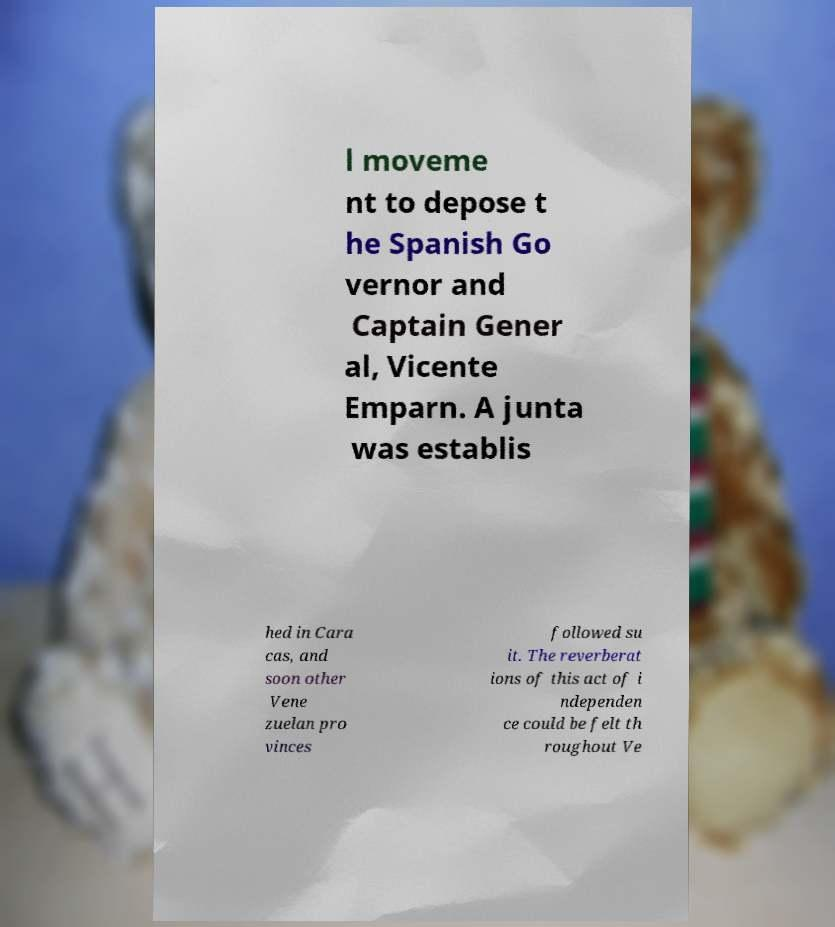For documentation purposes, I need the text within this image transcribed. Could you provide that? l moveme nt to depose t he Spanish Go vernor and Captain Gener al, Vicente Emparn. A junta was establis hed in Cara cas, and soon other Vene zuelan pro vinces followed su it. The reverberat ions of this act of i ndependen ce could be felt th roughout Ve 